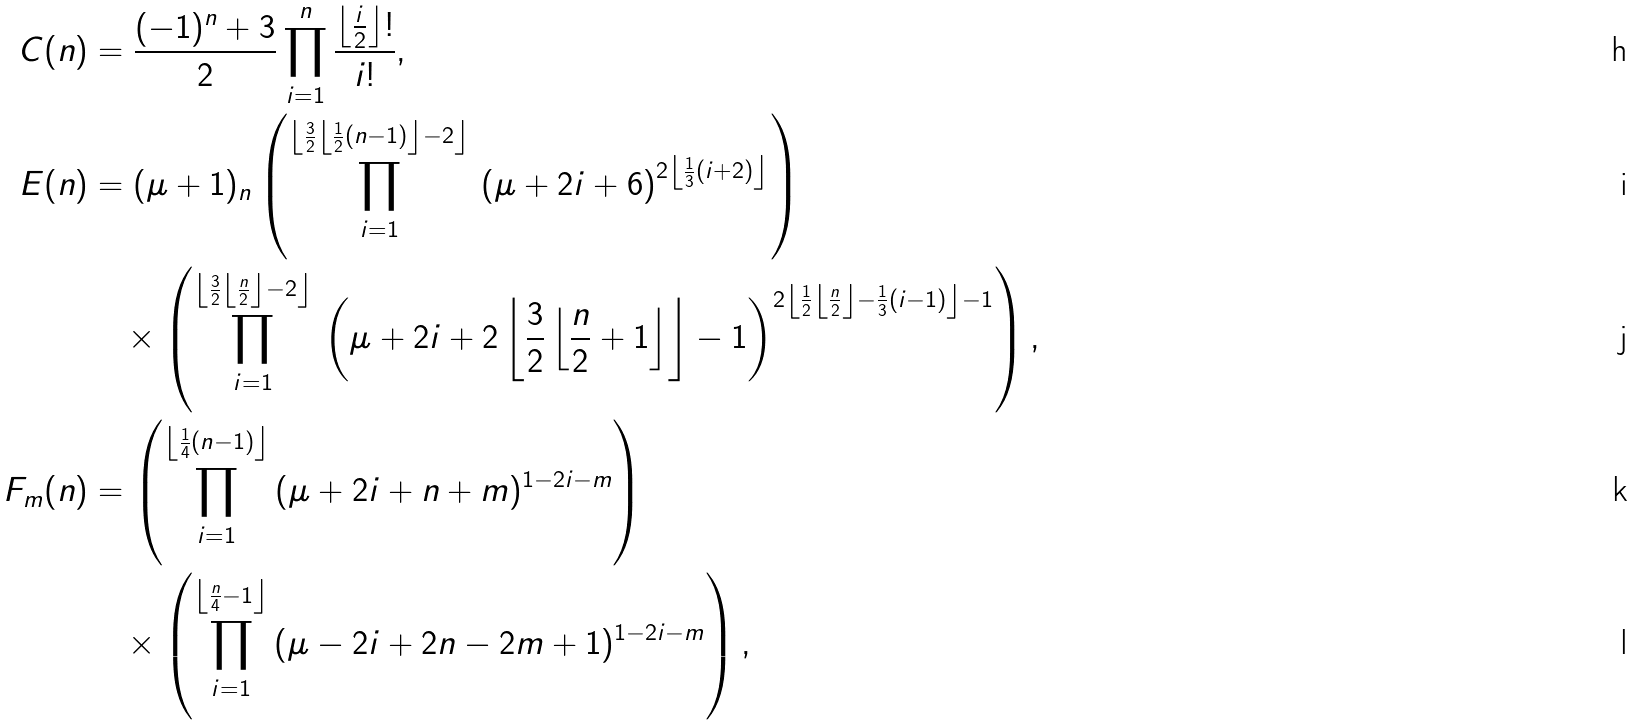<formula> <loc_0><loc_0><loc_500><loc_500>C ( n ) & = \frac { ( - 1 ) ^ { n } + 3 } { 2 } \prod _ { i = 1 } ^ { n } \frac { \left \lfloor \frac { i } { 2 } \right \rfloor ! } { i ! } , \\ E ( n ) & = ( \mu + 1 ) _ { n } \left ( \prod _ { i = 1 } ^ { \left \lfloor \frac { 3 } { 2 } \left \lfloor \frac { 1 } { 2 } ( n - 1 ) \right \rfloor - 2 \right \rfloor } \, \left ( \mu + 2 i + 6 \right ) ^ { 2 \left \lfloor \frac { 1 } { 3 } ( i + 2 ) \right \rfloor } \right ) \\ & \quad \times \left ( \prod _ { i = 1 } ^ { \left \lfloor \frac { 3 } { 2 } \left \lfloor \frac { n } { 2 } \right \rfloor - 2 \right \rfloor } \, \left ( \mu + 2 i + { 2 \left \lfloor \frac { 3 } { 2 } \left \lfloor \frac { n } { 2 } + 1 \right \rfloor \right \rfloor } - 1 \right ) ^ { 2 \left \lfloor \frac { 1 } { 2 } \left \lfloor \frac { n } { 2 } \right \rfloor - \frac { 1 } { 3 } ( i - 1 ) \right \rfloor - 1 } \right ) , \\ F _ { m } ( n ) & = \left ( \prod _ { i = 1 } ^ { \left \lfloor \frac { 1 } { 4 } ( n - 1 ) \right \rfloor } \, ( \mu + 2 i + n + m ) ^ { 1 - 2 i - m } \right ) \\ & \quad \times \left ( \prod _ { i = 1 } ^ { \left \lfloor \frac { n } { 4 } - 1 \right \rfloor } \, ( \mu - 2 i + 2 n - 2 m + 1 ) ^ { 1 - 2 i - m } \right ) ,</formula> 